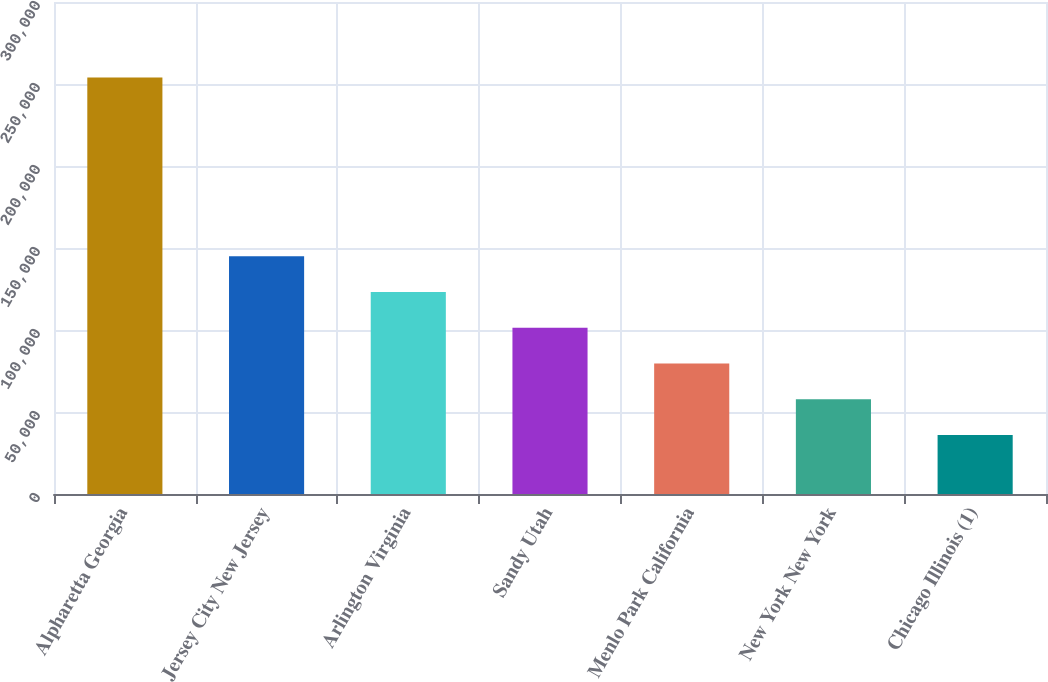<chart> <loc_0><loc_0><loc_500><loc_500><bar_chart><fcel>Alpharetta Georgia<fcel>Jersey City New Jersey<fcel>Arlington Virginia<fcel>Sandy Utah<fcel>Menlo Park California<fcel>New York New York<fcel>Chicago Illinois (1)<nl><fcel>254000<fcel>145000<fcel>123200<fcel>101400<fcel>79600<fcel>57800<fcel>36000<nl></chart> 